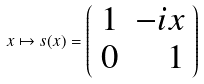<formula> <loc_0><loc_0><loc_500><loc_500>x \mapsto s ( x ) = \left ( \begin{array} { l r } 1 & - i x \\ 0 & 1 \end{array} \right )</formula> 